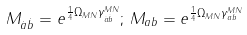<formula> <loc_0><loc_0><loc_500><loc_500>M _ { \dot { a } \dot { b } } = e ^ { \frac { 1 } { 4 } \Omega _ { M N } \gamma ^ { M N } _ { \dot { a } \dot { b } } } ; \, M _ { a b } = e ^ { \frac { 1 } { 4 } \Omega _ { M N } \gamma ^ { M N } _ { a b } }</formula> 